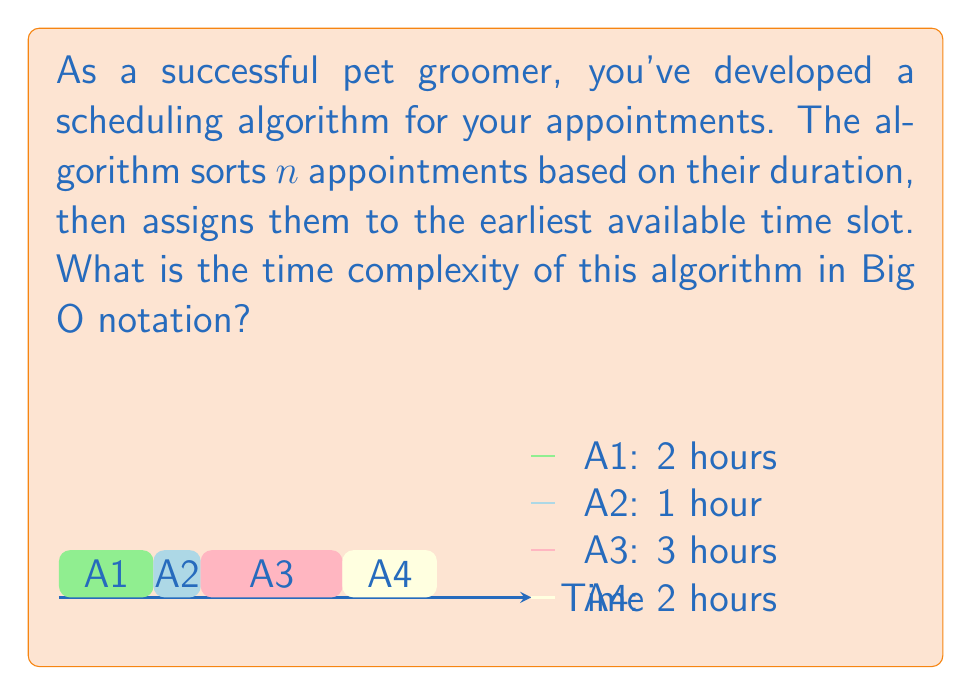Teach me how to tackle this problem. Let's break down the algorithm and analyze its time complexity step by step:

1. Sorting the appointments:
   The algorithm first sorts n appointments based on their duration. Using an efficient sorting algorithm like Merge Sort or Quick Sort, this step has a time complexity of $O(n \log n)$.

2. Assigning appointments to time slots:
   After sorting, the algorithm iterates through the sorted list of appointments once, assigning each to the earliest available time slot. This step has a linear time complexity of $O(n)$.

3. Overall time complexity:
   The total time complexity is the sum of the complexities of both steps:
   $$T(n) = O(n \log n) + O(n)$$

4. Simplifying the expression:
   Since $O(n \log n)$ grows faster than $O(n)$ for large values of n, we can simplify the expression by keeping only the dominant term:
   $$T(n) = O(n \log n)$$

Therefore, the overall time complexity of the scheduling algorithm is $O(n \log n)$.

This complexity is primarily due to the sorting step, which is the most time-consuming part of the algorithm. The subsequent linear-time assignment step does not affect the overall big O complexity.
Answer: $O(n \log n)$ 